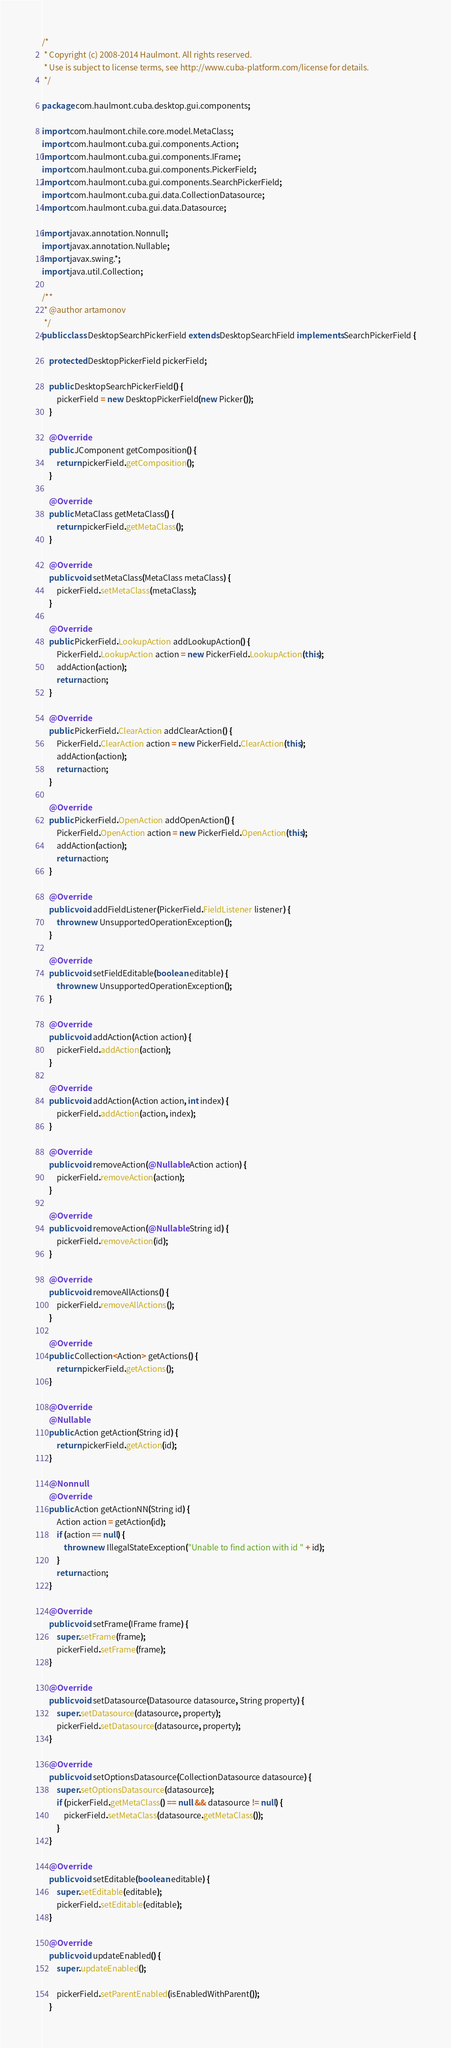Convert code to text. <code><loc_0><loc_0><loc_500><loc_500><_Java_>/*
 * Copyright (c) 2008-2014 Haulmont. All rights reserved.
 * Use is subject to license terms, see http://www.cuba-platform.com/license for details.
 */

package com.haulmont.cuba.desktop.gui.components;

import com.haulmont.chile.core.model.MetaClass;
import com.haulmont.cuba.gui.components.Action;
import com.haulmont.cuba.gui.components.IFrame;
import com.haulmont.cuba.gui.components.PickerField;
import com.haulmont.cuba.gui.components.SearchPickerField;
import com.haulmont.cuba.gui.data.CollectionDatasource;
import com.haulmont.cuba.gui.data.Datasource;

import javax.annotation.Nonnull;
import javax.annotation.Nullable;
import javax.swing.*;
import java.util.Collection;

/**
 * @author artamonov
 */
public class DesktopSearchPickerField extends DesktopSearchField implements SearchPickerField {

    protected DesktopPickerField pickerField;

    public DesktopSearchPickerField() {
        pickerField = new DesktopPickerField(new Picker());
    }

    @Override
    public JComponent getComposition() {
        return pickerField.getComposition();
    }

    @Override
    public MetaClass getMetaClass() {
        return pickerField.getMetaClass();
    }

    @Override
    public void setMetaClass(MetaClass metaClass) {
        pickerField.setMetaClass(metaClass);
    }

    @Override
    public PickerField.LookupAction addLookupAction() {
        PickerField.LookupAction action = new PickerField.LookupAction(this);
        addAction(action);
        return action;
    }

    @Override
    public PickerField.ClearAction addClearAction() {
        PickerField.ClearAction action = new PickerField.ClearAction(this);
        addAction(action);
        return action;
    }

    @Override
    public PickerField.OpenAction addOpenAction() {
        PickerField.OpenAction action = new PickerField.OpenAction(this);
        addAction(action);
        return action;
    }

    @Override
    public void addFieldListener(PickerField.FieldListener listener) {
        throw new UnsupportedOperationException();
    }

    @Override
    public void setFieldEditable(boolean editable) {
        throw new UnsupportedOperationException();
    }

    @Override
    public void addAction(Action action) {
        pickerField.addAction(action);
    }

    @Override
    public void addAction(Action action, int index) {
        pickerField.addAction(action, index);
    }

    @Override
    public void removeAction(@Nullable Action action) {
        pickerField.removeAction(action);
    }

    @Override
    public void removeAction(@Nullable String id) {
        pickerField.removeAction(id);
    }

    @Override
    public void removeAllActions() {
        pickerField.removeAllActions();
    }

    @Override
    public Collection<Action> getActions() {
        return pickerField.getActions();
    }

    @Override
    @Nullable
    public Action getAction(String id) {
        return pickerField.getAction(id);
    }

    @Nonnull
    @Override
    public Action getActionNN(String id) {
        Action action = getAction(id);
        if (action == null) {
            throw new IllegalStateException("Unable to find action with id " + id);
        }
        return action;
    }

    @Override
    public void setFrame(IFrame frame) {
        super.setFrame(frame);
        pickerField.setFrame(frame);
    }

    @Override
    public void setDatasource(Datasource datasource, String property) {
        super.setDatasource(datasource, property);
        pickerField.setDatasource(datasource, property);
    }

    @Override
    public void setOptionsDatasource(CollectionDatasource datasource) {
        super.setOptionsDatasource(datasource);
        if (pickerField.getMetaClass() == null && datasource != null) {
            pickerField.setMetaClass(datasource.getMetaClass());
        }
    }

    @Override
    public void setEditable(boolean editable) {
        super.setEditable(editable);
        pickerField.setEditable(editable);
    }

    @Override
    public void updateEnabled() {
        super.updateEnabled();

        pickerField.setParentEnabled(isEnabledWithParent());
    }
</code> 